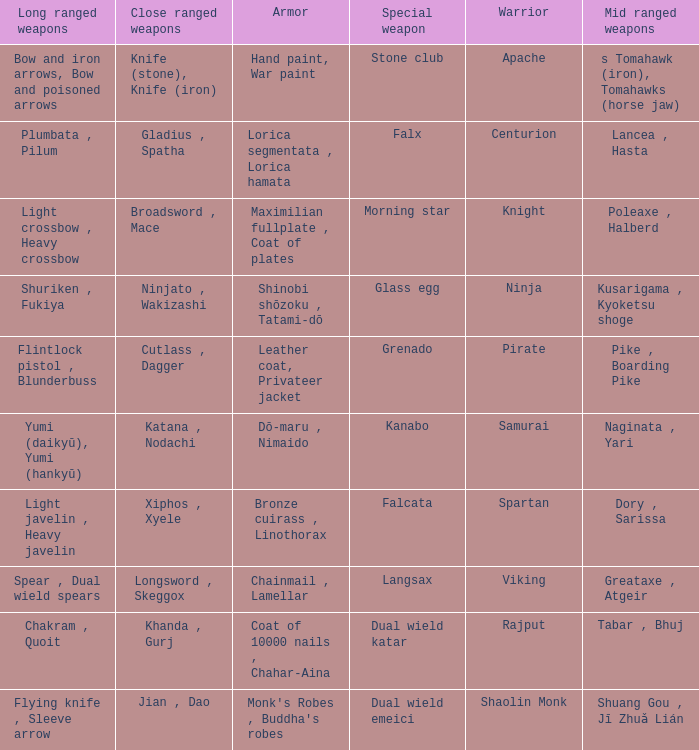If the special weapon is the Grenado, what is the armor? Leather coat, Privateer jacket. 